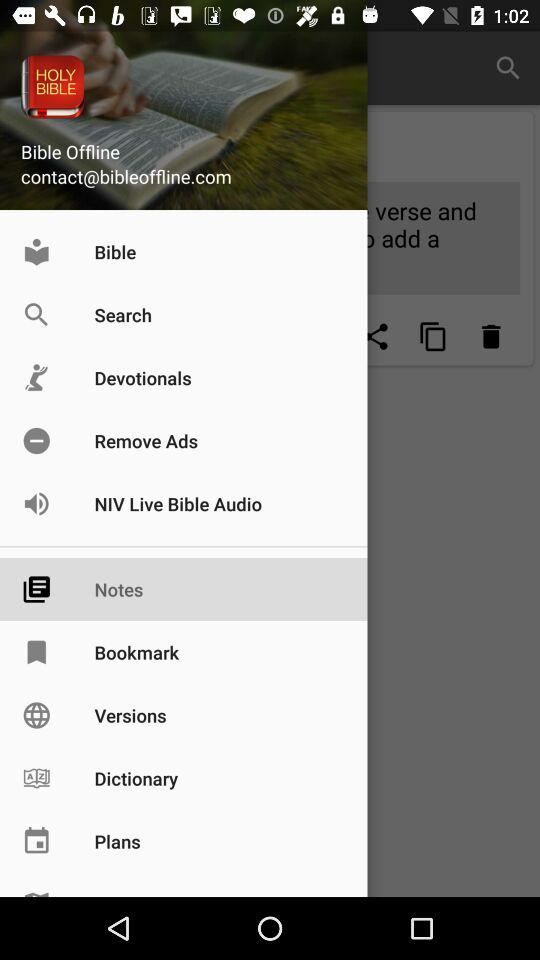What's the username? The username is Bible Offline. 